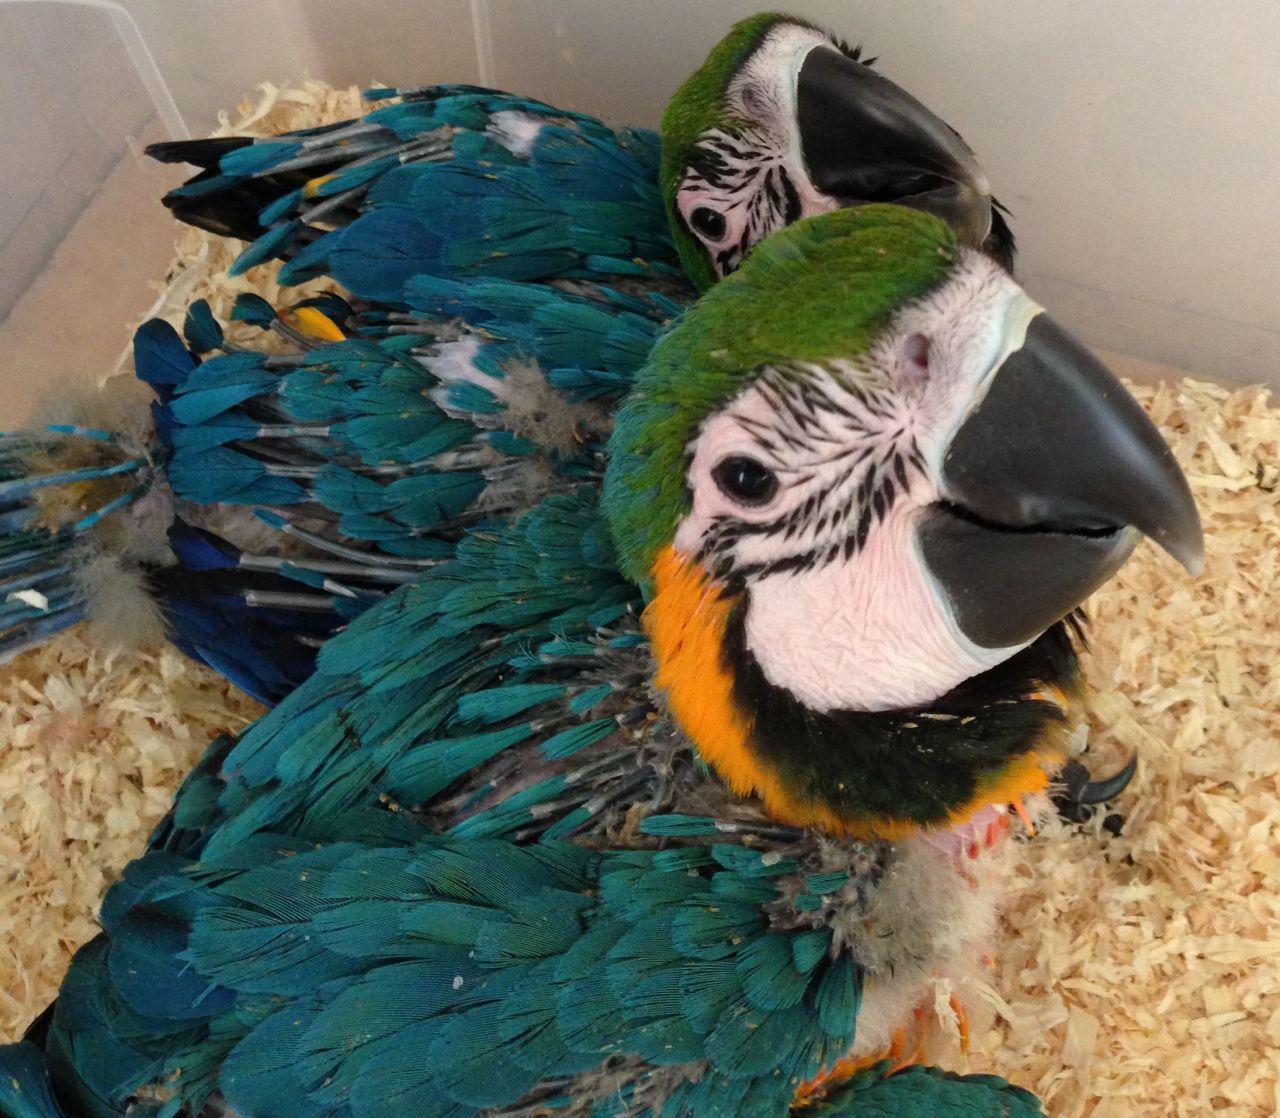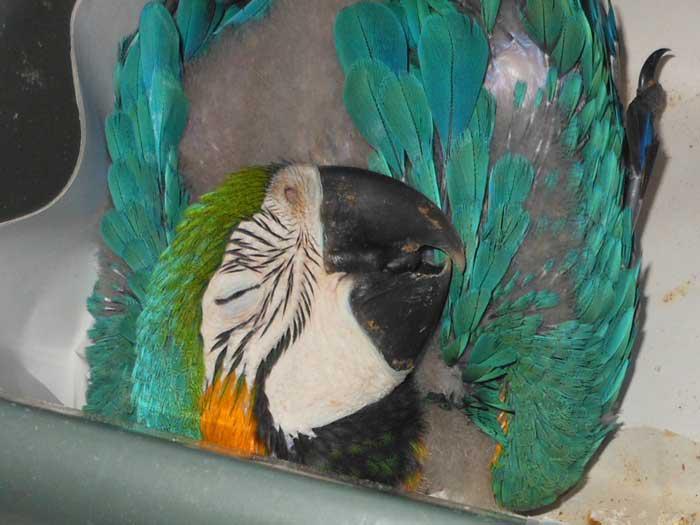The first image is the image on the left, the second image is the image on the right. Examine the images to the left and right. Is the description "In one image there is a blue parrot sitting on a perch in the center of the image." accurate? Answer yes or no. No. The first image is the image on the left, the second image is the image on the right. Considering the images on both sides, is "there are 3 parrots in the image pair" valid? Answer yes or no. Yes. 